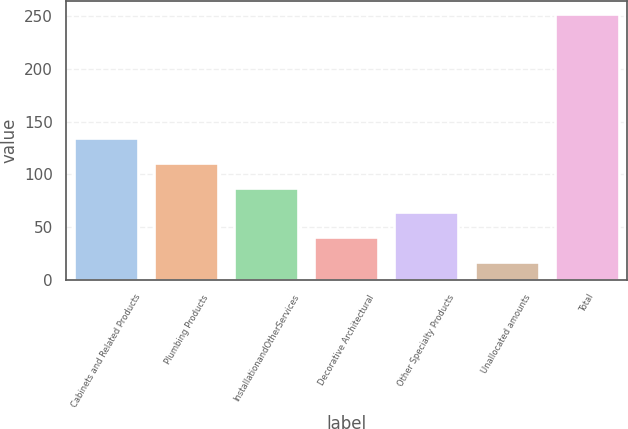<chart> <loc_0><loc_0><loc_500><loc_500><bar_chart><fcel>Cabinets and Related Products<fcel>Plumbing Products<fcel>InstallationandOtherServices<fcel>Decorative Architectural<fcel>Other Specialty Products<fcel>Unallocated amounts<fcel>Total<nl><fcel>134.5<fcel>111<fcel>87.5<fcel>40.5<fcel>64<fcel>17<fcel>252<nl></chart> 